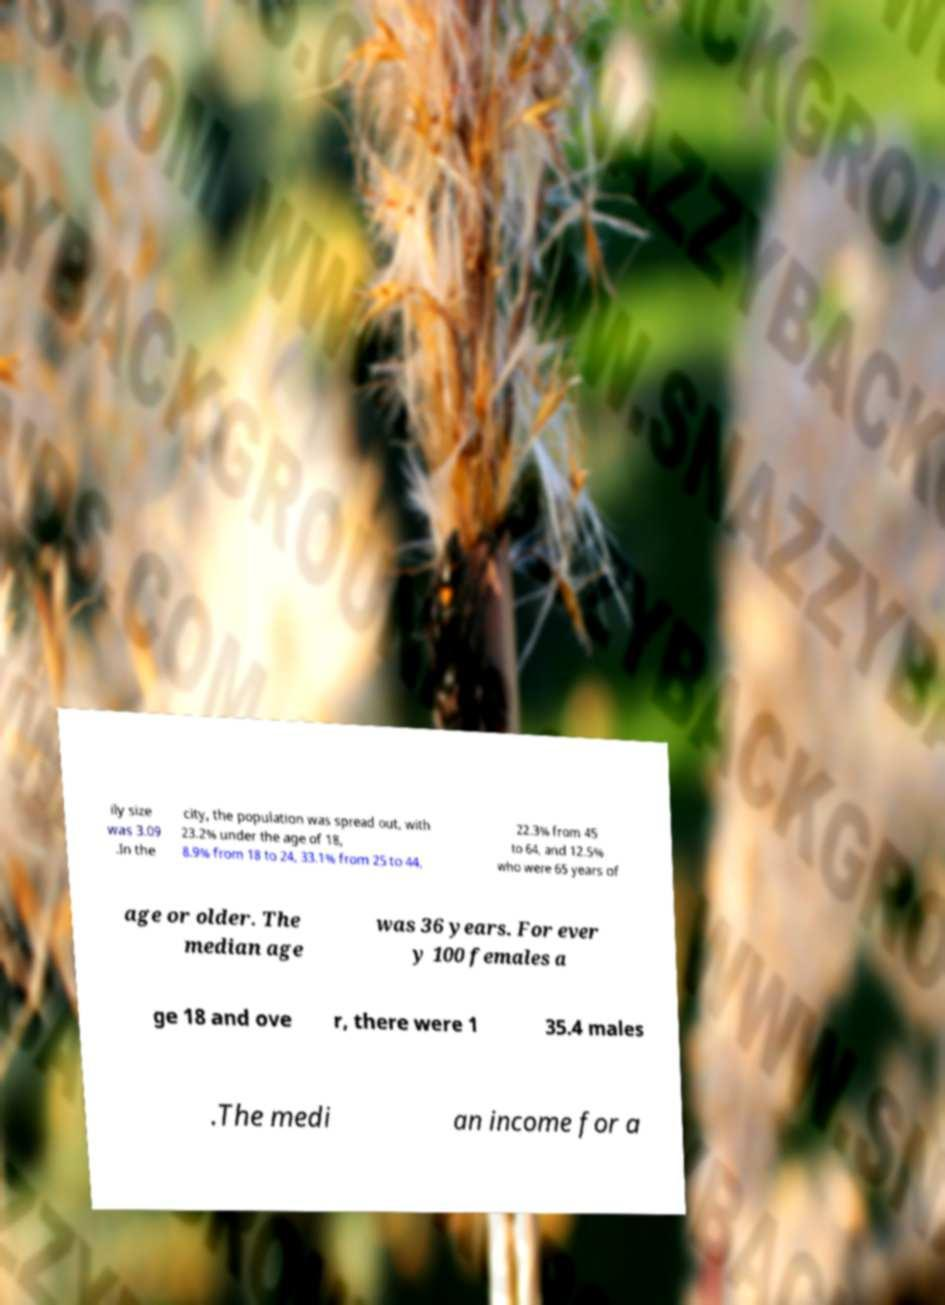Can you read and provide the text displayed in the image?This photo seems to have some interesting text. Can you extract and type it out for me? ily size was 3.09 .In the city, the population was spread out, with 23.2% under the age of 18, 8.9% from 18 to 24, 33.1% from 25 to 44, 22.3% from 45 to 64, and 12.5% who were 65 years of age or older. The median age was 36 years. For ever y 100 females a ge 18 and ove r, there were 1 35.4 males .The medi an income for a 